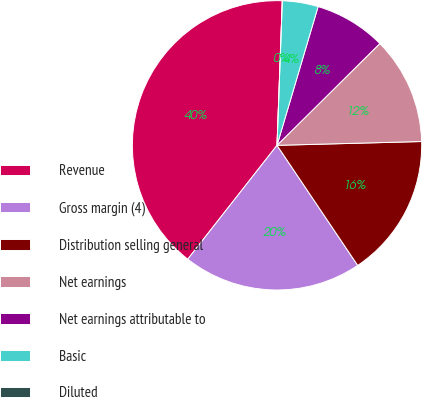Convert chart to OTSL. <chart><loc_0><loc_0><loc_500><loc_500><pie_chart><fcel>Revenue<fcel>Gross margin (4)<fcel>Distribution selling general<fcel>Net earnings<fcel>Net earnings attributable to<fcel>Basic<fcel>Diluted<nl><fcel>40.0%<fcel>20.0%<fcel>16.0%<fcel>12.0%<fcel>8.0%<fcel>4.0%<fcel>0.0%<nl></chart> 